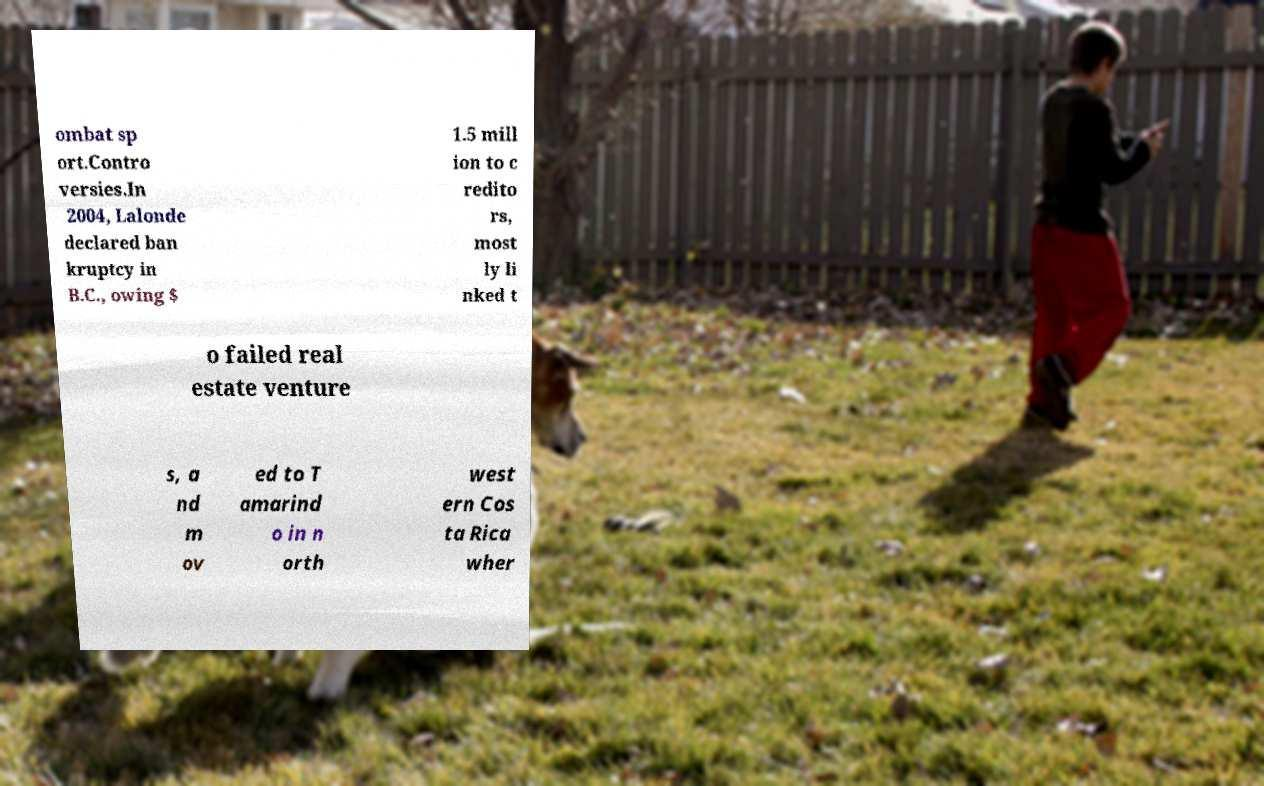Can you accurately transcribe the text from the provided image for me? ombat sp ort.Contro versies.In 2004, Lalonde declared ban kruptcy in B.C., owing $ 1.5 mill ion to c redito rs, most ly li nked t o failed real estate venture s, a nd m ov ed to T amarind o in n orth west ern Cos ta Rica wher 